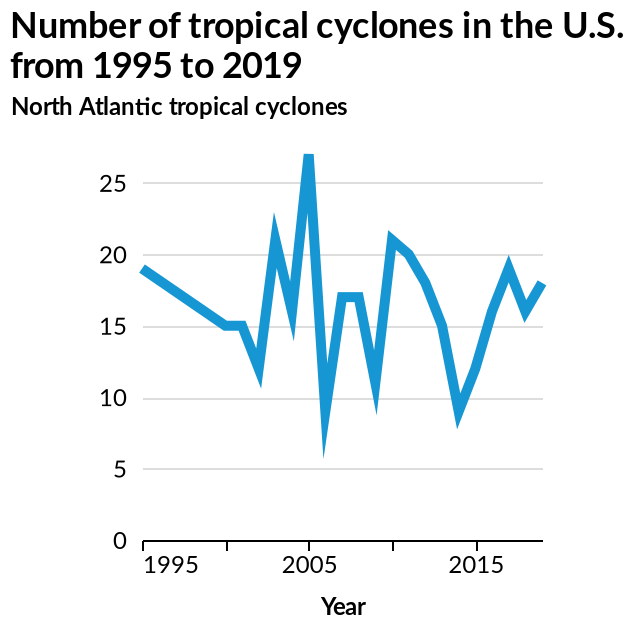<image>
Offer a thorough analysis of the image. 2005 had the most cyclones with over 25 that year. 2006 had the lowest. There are at least 5 cyclones per year. The amount seems to vary per year. What is the time range covered by the line graph? The line graph covers the period from 1995 to 2019. 